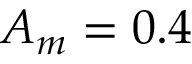Convert formula to latex. <formula><loc_0><loc_0><loc_500><loc_500>A _ { m } = 0 . 4</formula> 